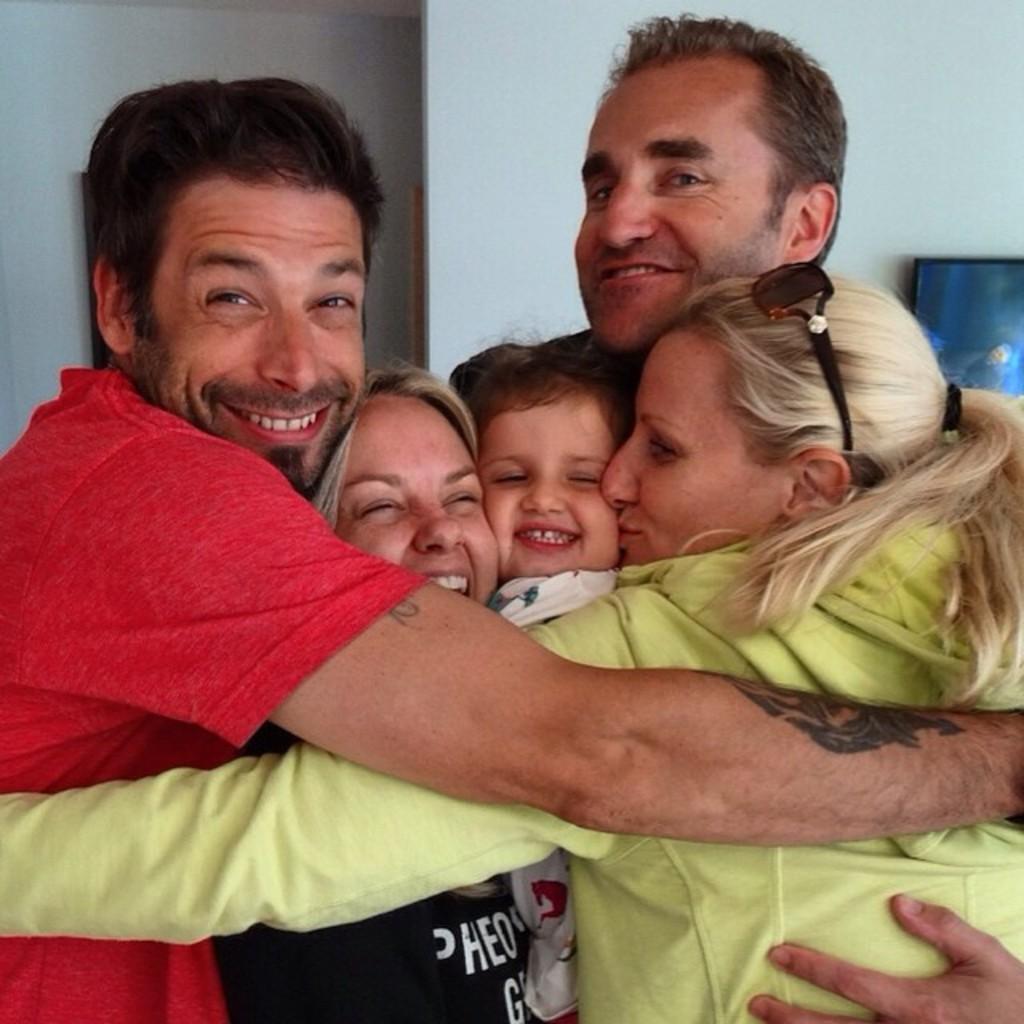Could you give a brief overview of what you see in this image? In this image, we can see men, women and a kid smiling. In the background, there is a frame placed on the wall. 